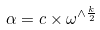<formula> <loc_0><loc_0><loc_500><loc_500>\alpha = c \times \omega ^ { \wedge \frac { k } { 2 } }</formula> 